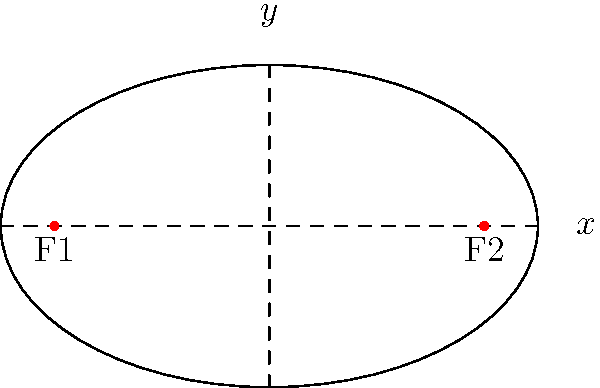As a hairstylist creating a symmetrical bridal updo, you're inspired by the elegant shape of an ellipse. The equation of this ellipse is given by $\frac{x^2}{25} + \frac{y^2}{9} = 1$. Find the coordinates of the focal points of this ellipse, which could represent the placement of decorative hair pins in your updo design. To find the focal points of the ellipse, we'll follow these steps:

1) The general form of an ellipse equation is $\frac{x^2}{a^2} + \frac{y^2}{b^2} = 1$, where $a$ is the length of the semi-major axis and $b$ is the length of the semi-minor axis.

2) From our equation $\frac{x^2}{25} + \frac{y^2}{9} = 1$, we can identify:
   $a^2 = 25$, so $a = 5$
   $b^2 = 9$, so $b = 3$

3) The focal points of an ellipse lie on its major axis. The distance from the center to a focal point, let's call it $c$, is related to $a$ and $b$ by the equation:
   $c^2 = a^2 - b^2$

4) Substituting our values:
   $c^2 = 5^2 - 3^2 = 25 - 9 = 16$

5) Taking the square root:
   $c = \sqrt{16} = 4$

6) Since the ellipse is centered at the origin (0,0), the focal points are located at:
   $(-c, 0)$ and $(c, 0)$, which are $(-4, 0)$ and $(4, 0)$

Therefore, the focal points of the ellipse are at $(-4, 0)$ and $(4, 0)$.
Answer: $(-4, 0)$ and $(4, 0)$ 